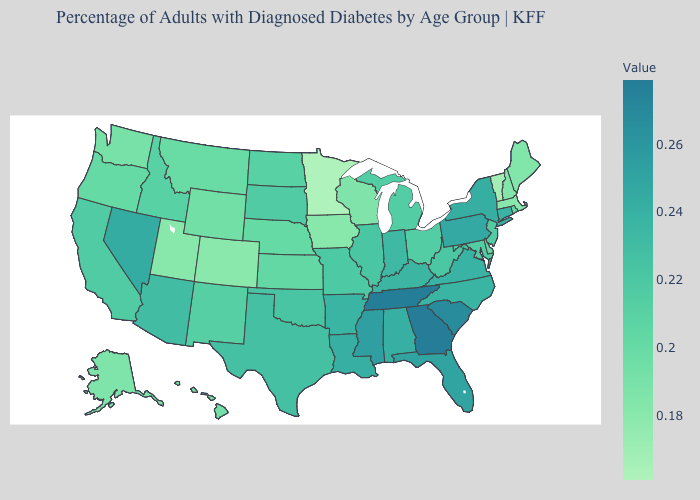Does the map have missing data?
Write a very short answer. No. Which states hav the highest value in the MidWest?
Give a very brief answer. Indiana. Among the states that border New Hampshire , which have the highest value?
Write a very short answer. Maine. Among the states that border Mississippi , does Louisiana have the lowest value?
Quick response, please. No. Which states hav the highest value in the MidWest?
Quick response, please. Indiana. Does the map have missing data?
Quick response, please. No. Does the map have missing data?
Give a very brief answer. No. Does Kansas have the highest value in the USA?
Give a very brief answer. No. 